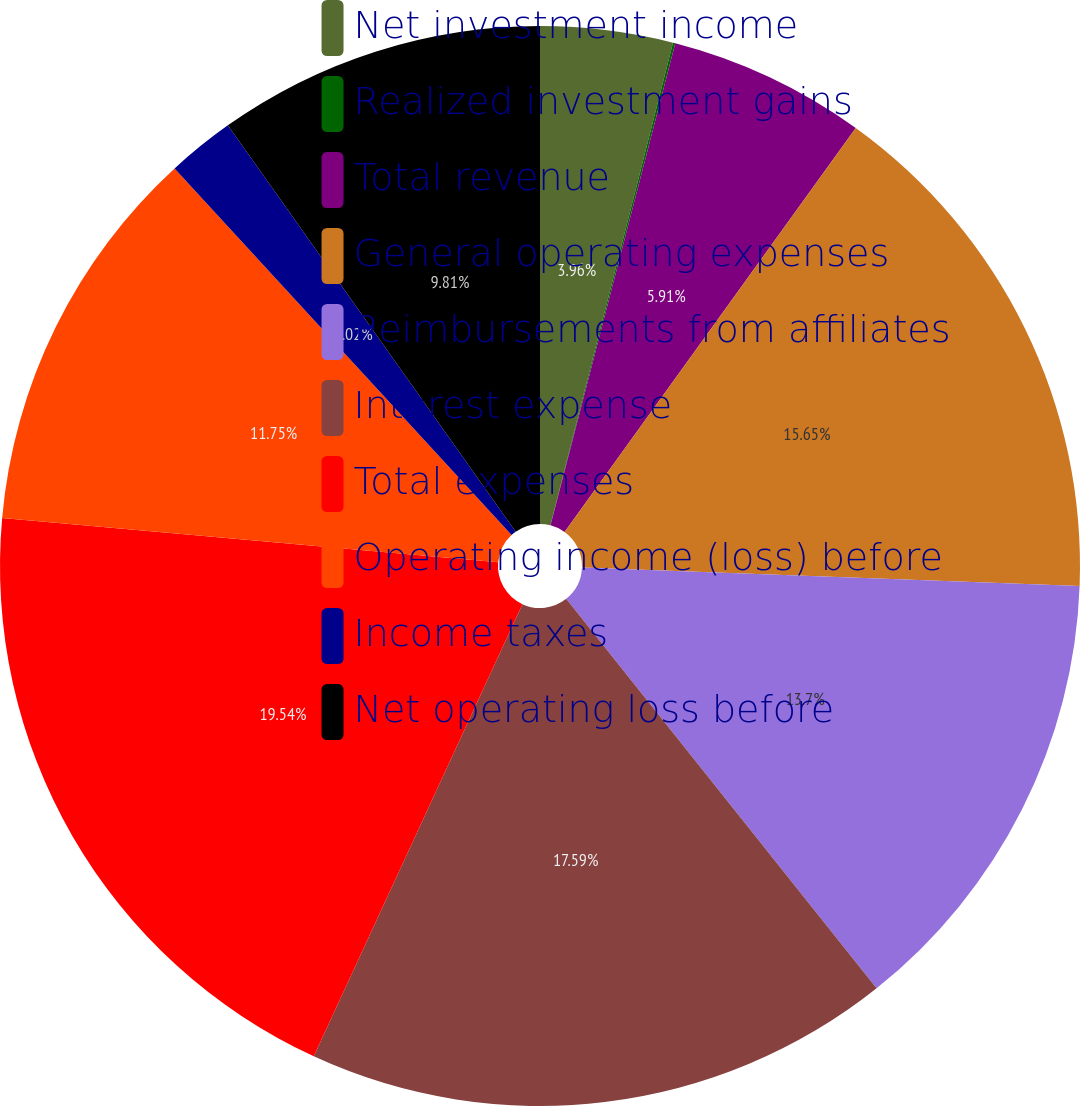Convert chart to OTSL. <chart><loc_0><loc_0><loc_500><loc_500><pie_chart><fcel>Net investment income<fcel>Realized investment gains<fcel>Total revenue<fcel>General operating expenses<fcel>Reimbursements from affiliates<fcel>Interest expense<fcel>Total expenses<fcel>Operating income (loss) before<fcel>Income taxes<fcel>Net operating loss before<nl><fcel>3.96%<fcel>0.07%<fcel>5.91%<fcel>15.65%<fcel>13.7%<fcel>17.59%<fcel>19.54%<fcel>11.75%<fcel>2.02%<fcel>9.81%<nl></chart> 